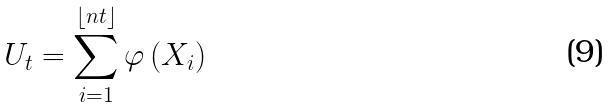<formula> <loc_0><loc_0><loc_500><loc_500>U _ { t } = \sum _ { i = 1 } ^ { \lfloor n t \rfloor } \varphi \left ( X _ { i } \right )</formula> 